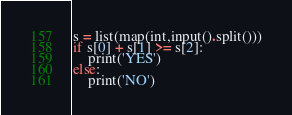Convert code to text. <code><loc_0><loc_0><loc_500><loc_500><_Python_>s = list(map(int,input().split()))
if s[0] + s[1] >= s[2]:
    print('YES')
else:
    print('NO')</code> 